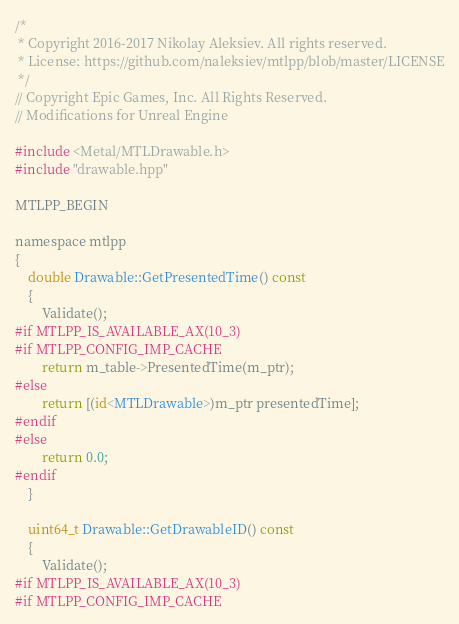Convert code to text. <code><loc_0><loc_0><loc_500><loc_500><_ObjectiveC_>/*
 * Copyright 2016-2017 Nikolay Aleksiev. All rights reserved.
 * License: https://github.com/naleksiev/mtlpp/blob/master/LICENSE
 */
// Copyright Epic Games, Inc. All Rights Reserved.
// Modifications for Unreal Engine

#include <Metal/MTLDrawable.h>
#include "drawable.hpp"

MTLPP_BEGIN

namespace mtlpp
{
    double Drawable::GetPresentedTime() const
    {
        Validate();
#if MTLPP_IS_AVAILABLE_AX(10_3)
#if MTLPP_CONFIG_IMP_CACHE
		return m_table->PresentedTime(m_ptr);
#else
        return [(id<MTLDrawable>)m_ptr presentedTime];
#endif
#else
        return 0.0;
#endif
    }

    uint64_t Drawable::GetDrawableID() const
    {
        Validate();
#if MTLPP_IS_AVAILABLE_AX(10_3)
#if MTLPP_CONFIG_IMP_CACHE</code> 